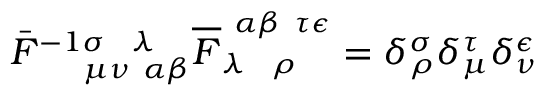Convert formula to latex. <formula><loc_0><loc_0><loc_500><loc_500>\bar { F } _ { \mu \nu \alpha \beta } ^ { - 1 \sigma \lambda } \overline { F } _ { \lambda \rho } ^ { \alpha \beta \tau \epsilon } = \delta _ { \rho } ^ { \sigma } \delta _ { \mu } ^ { \tau } \delta _ { \nu } ^ { \epsilon }</formula> 